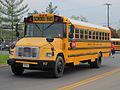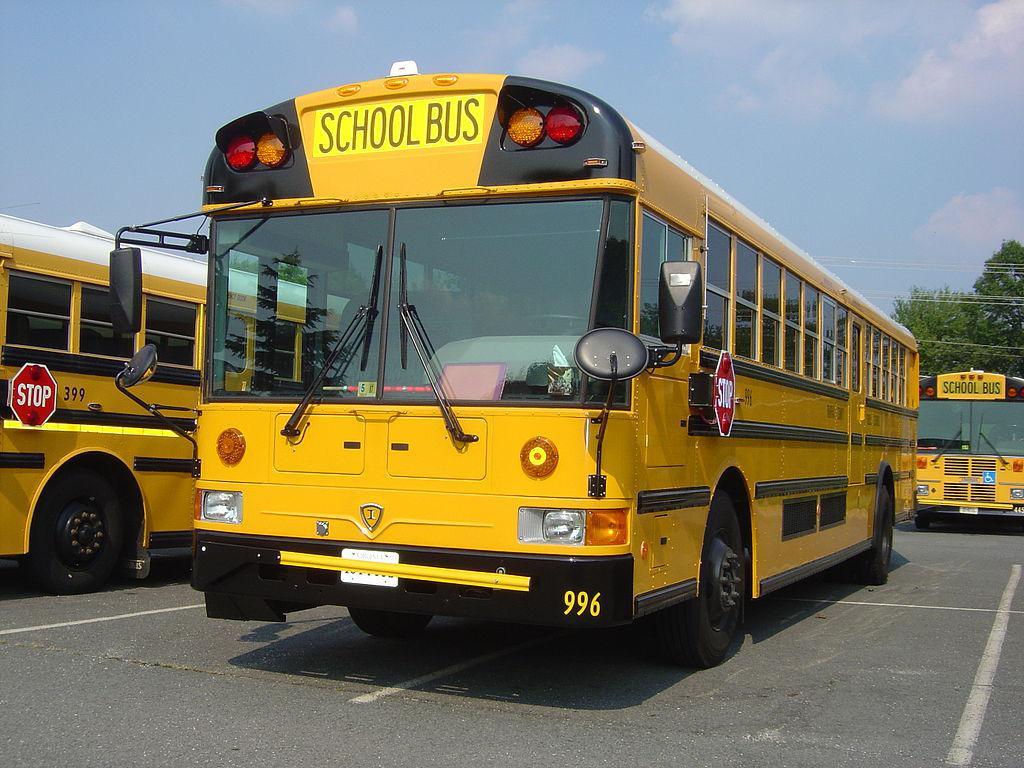The first image is the image on the left, the second image is the image on the right. Analyze the images presented: Is the assertion "The right image contains at least three school buses." valid? Answer yes or no. Yes. The first image is the image on the left, the second image is the image on the right. Considering the images on both sides, is "The door of the bus in the image on the right is open." valid? Answer yes or no. No. 